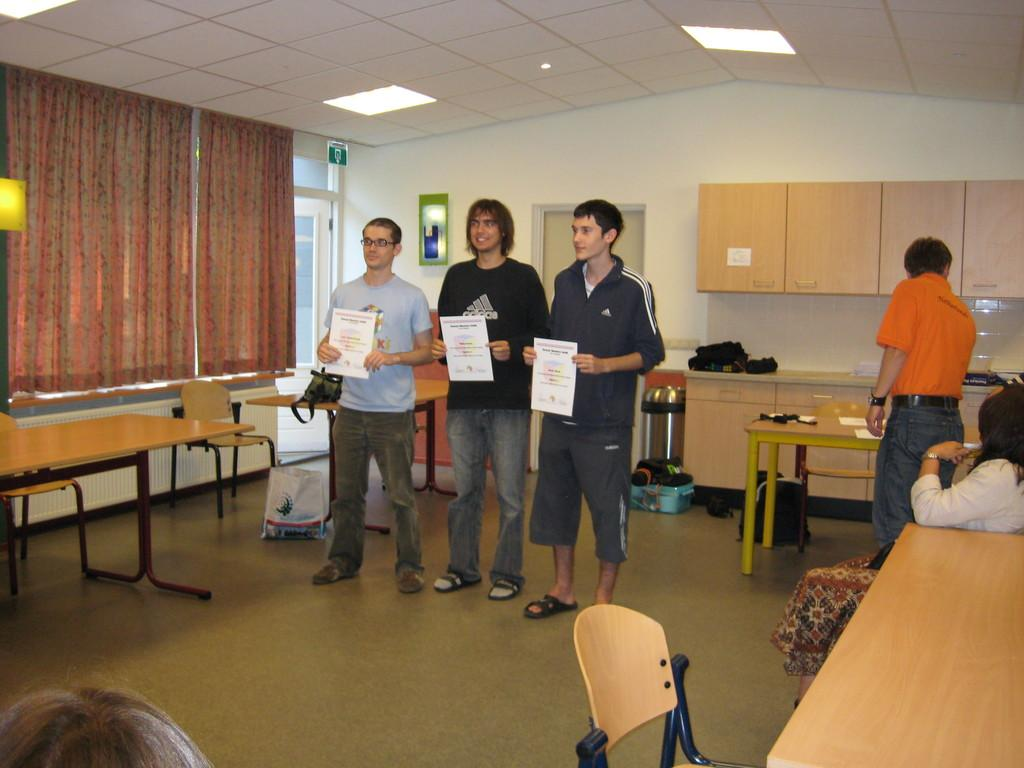How many people are in the center of the image? There are three persons standing in the center of the image. What are the three persons in the center holding? The three persons in the center are holding a paper. What is the gender of the person standing on the right side of the image? The gender of the person standing on the right side of the image is not specified in the facts. What is the woman on the right side of the image doing? The woman on the right side of the image is sitting. What type of insect can be seen crawling on the paper held by the three persons? There is no insect present in the image; it only shows three persons holding a paper and a person and woman on the right side. 